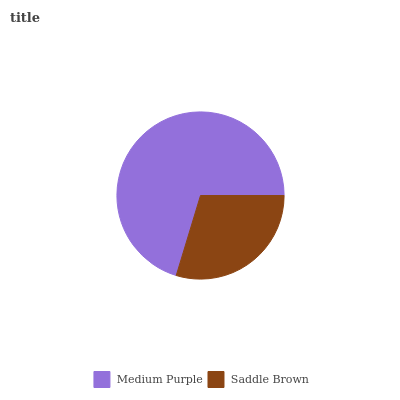Is Saddle Brown the minimum?
Answer yes or no. Yes. Is Medium Purple the maximum?
Answer yes or no. Yes. Is Saddle Brown the maximum?
Answer yes or no. No. Is Medium Purple greater than Saddle Brown?
Answer yes or no. Yes. Is Saddle Brown less than Medium Purple?
Answer yes or no. Yes. Is Saddle Brown greater than Medium Purple?
Answer yes or no. No. Is Medium Purple less than Saddle Brown?
Answer yes or no. No. Is Medium Purple the high median?
Answer yes or no. Yes. Is Saddle Brown the low median?
Answer yes or no. Yes. Is Saddle Brown the high median?
Answer yes or no. No. Is Medium Purple the low median?
Answer yes or no. No. 